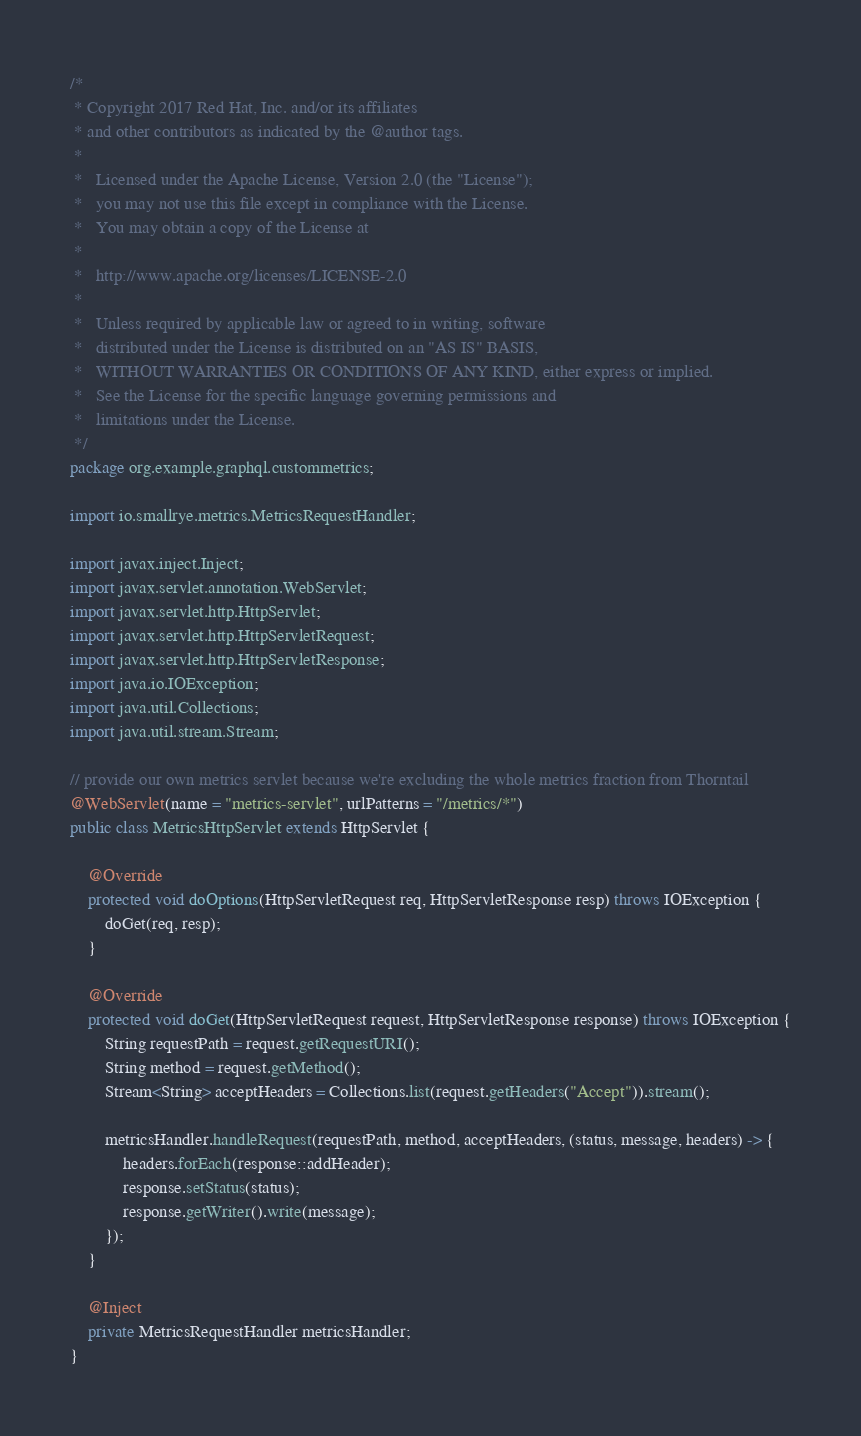Convert code to text. <code><loc_0><loc_0><loc_500><loc_500><_Java_>/*
 * Copyright 2017 Red Hat, Inc. and/or its affiliates
 * and other contributors as indicated by the @author tags.
 *
 *   Licensed under the Apache License, Version 2.0 (the "License");
 *   you may not use this file except in compliance with the License.
 *   You may obtain a copy of the License at
 *
 *   http://www.apache.org/licenses/LICENSE-2.0
 *
 *   Unless required by applicable law or agreed to in writing, software
 *   distributed under the License is distributed on an "AS IS" BASIS,
 *   WITHOUT WARRANTIES OR CONDITIONS OF ANY KIND, either express or implied.
 *   See the License for the specific language governing permissions and
 *   limitations under the License.
 */
package org.example.graphql.custommetrics;

import io.smallrye.metrics.MetricsRequestHandler;

import javax.inject.Inject;
import javax.servlet.annotation.WebServlet;
import javax.servlet.http.HttpServlet;
import javax.servlet.http.HttpServletRequest;
import javax.servlet.http.HttpServletResponse;
import java.io.IOException;
import java.util.Collections;
import java.util.stream.Stream;

// provide our own metrics servlet because we're excluding the whole metrics fraction from Thorntail
@WebServlet(name = "metrics-servlet", urlPatterns = "/metrics/*")
public class MetricsHttpServlet extends HttpServlet {

    @Override
    protected void doOptions(HttpServletRequest req, HttpServletResponse resp) throws IOException {
        doGet(req, resp);
    }

    @Override
    protected void doGet(HttpServletRequest request, HttpServletResponse response) throws IOException {
        String requestPath = request.getRequestURI();
        String method = request.getMethod();
        Stream<String> acceptHeaders = Collections.list(request.getHeaders("Accept")).stream();

        metricsHandler.handleRequest(requestPath, method, acceptHeaders, (status, message, headers) -> {
            headers.forEach(response::addHeader);
            response.setStatus(status);
            response.getWriter().write(message);
        });
    }

    @Inject
    private MetricsRequestHandler metricsHandler;
}
</code> 